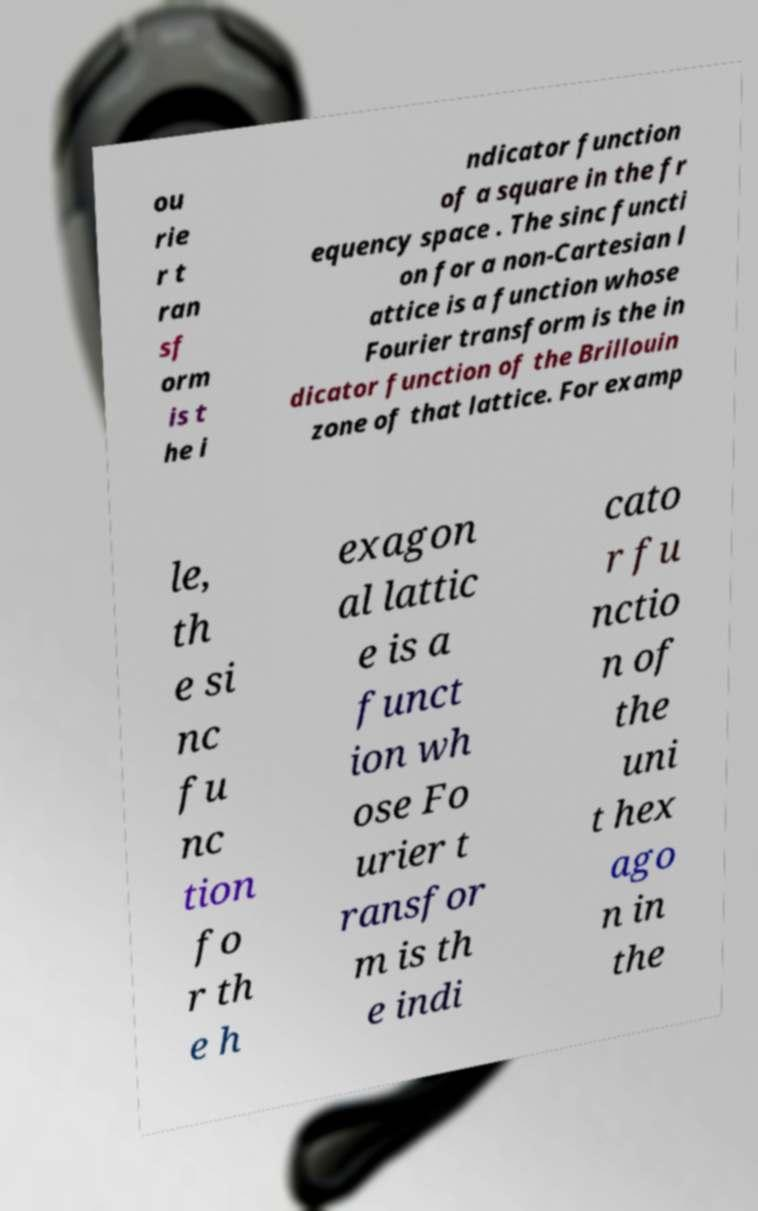Could you extract and type out the text from this image? ou rie r t ran sf orm is t he i ndicator function of a square in the fr equency space . The sinc functi on for a non-Cartesian l attice is a function whose Fourier transform is the in dicator function of the Brillouin zone of that lattice. For examp le, th e si nc fu nc tion fo r th e h exagon al lattic e is a funct ion wh ose Fo urier t ransfor m is th e indi cato r fu nctio n of the uni t hex ago n in the 